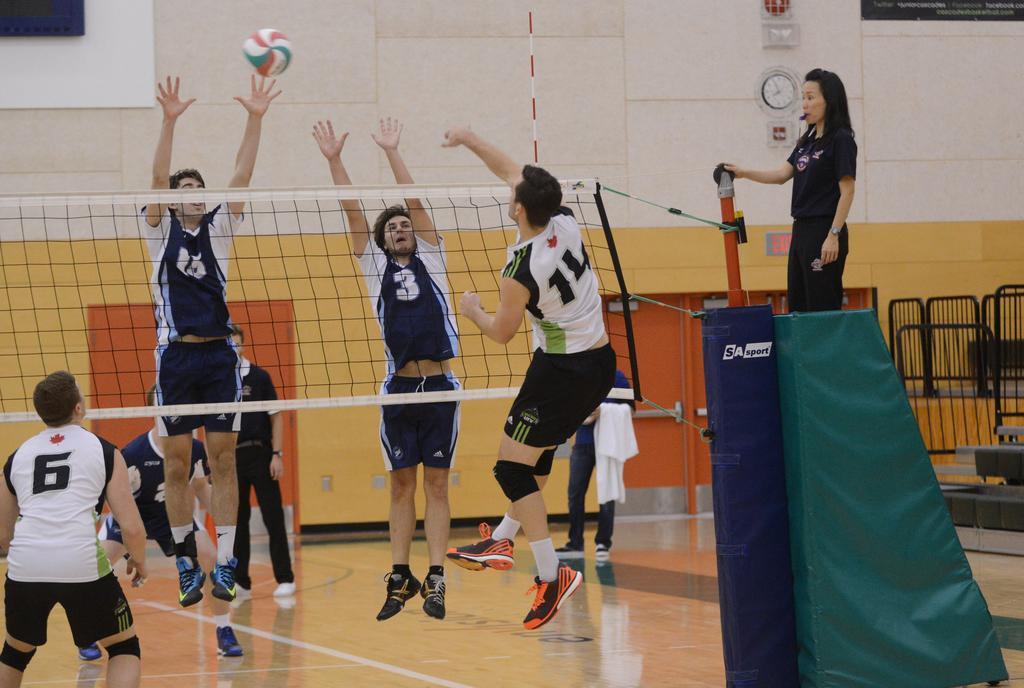How would you summarize this image in a sentence or two? As we can see in the image there is a wall, clock, ball, net, fence and few people here and there. 